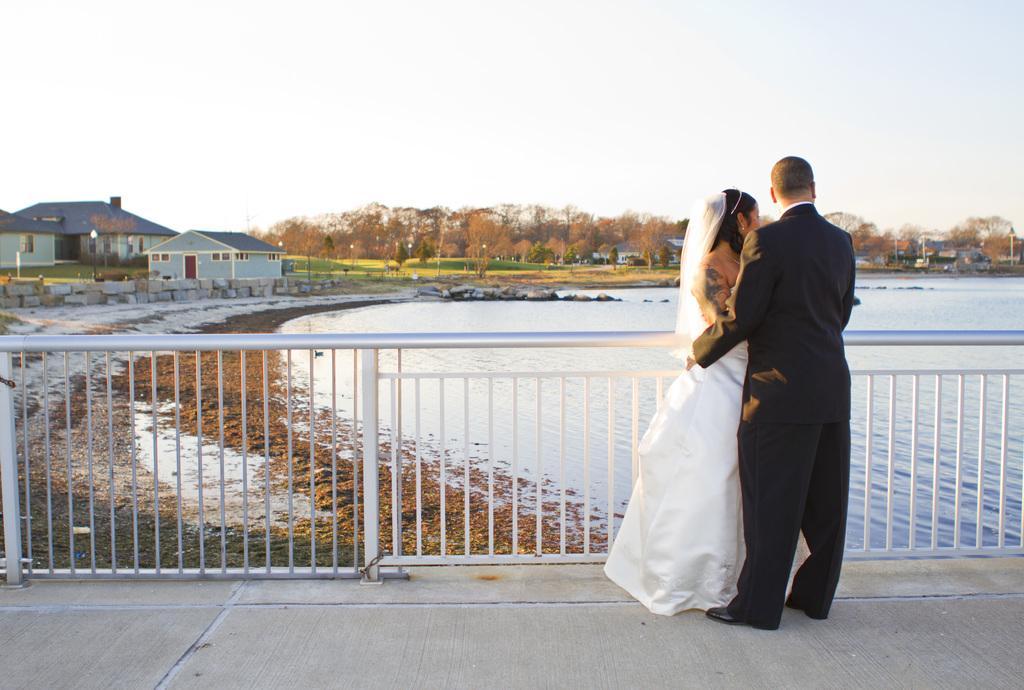Please provide a concise description of this image. There is a man and a woman on the road. Here we can see a fence, water, houses, poles, lights, and trees. This is grass. In the background we can see sky. 